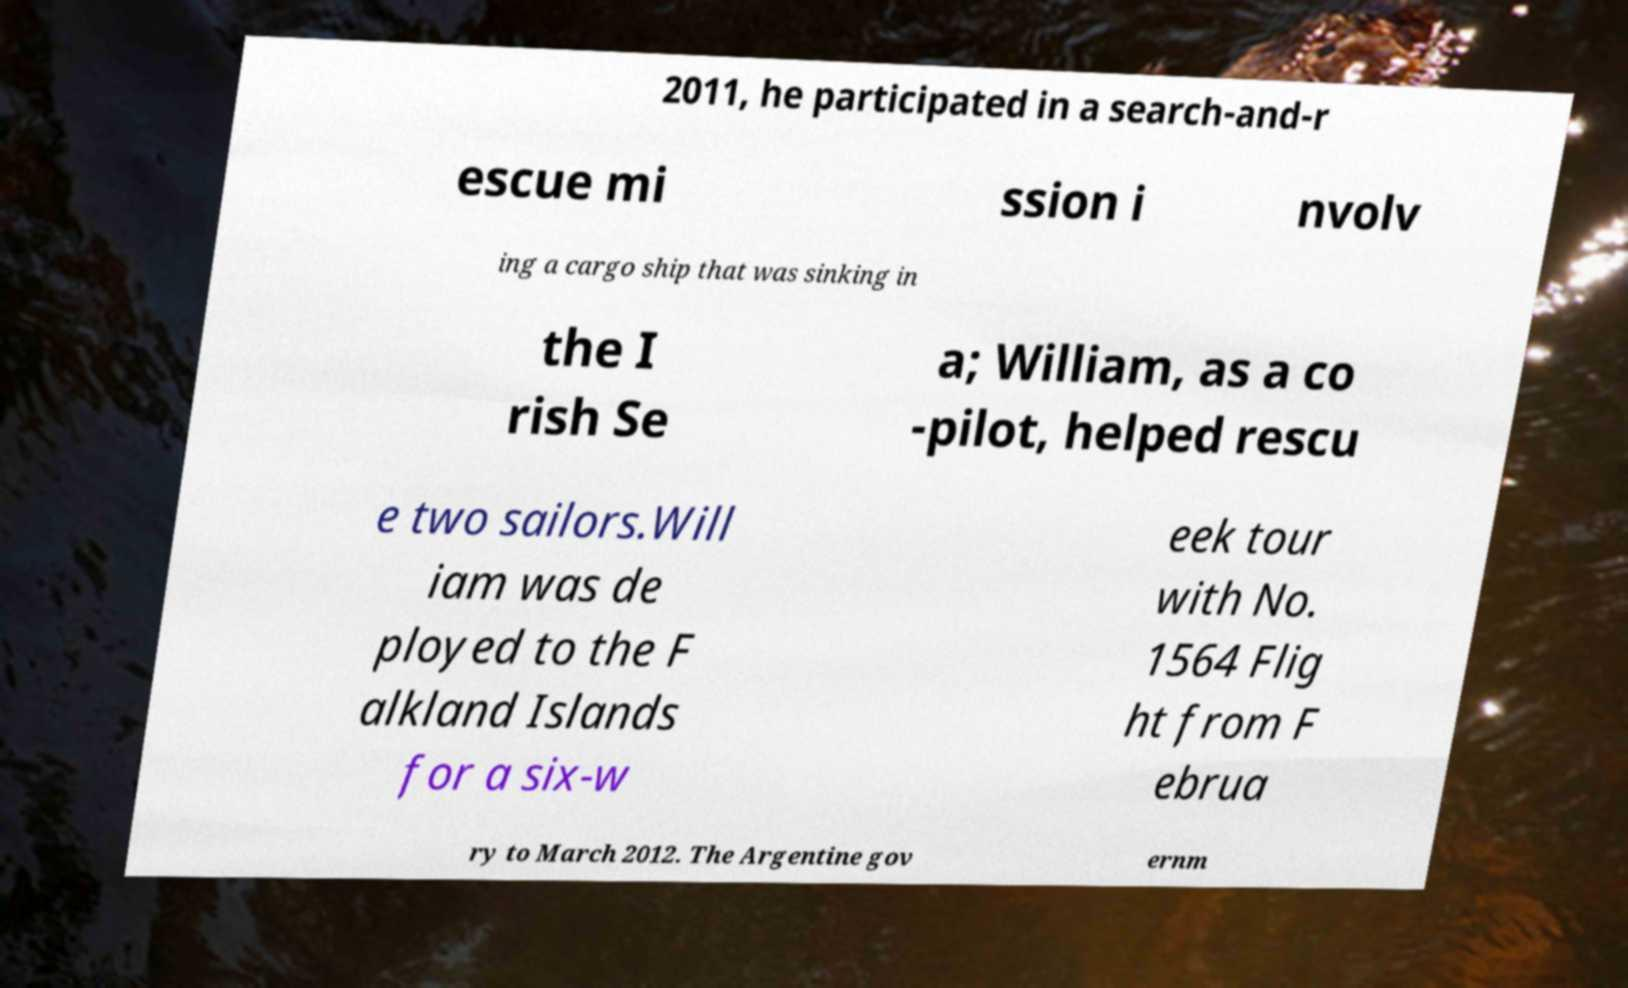Could you extract and type out the text from this image? 2011, he participated in a search-and-r escue mi ssion i nvolv ing a cargo ship that was sinking in the I rish Se a; William, as a co -pilot, helped rescu e two sailors.Will iam was de ployed to the F alkland Islands for a six-w eek tour with No. 1564 Flig ht from F ebrua ry to March 2012. The Argentine gov ernm 